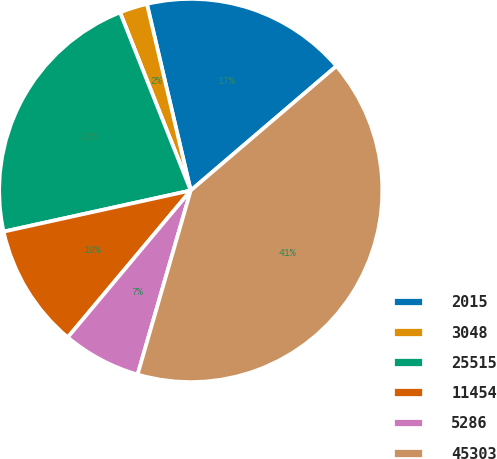Convert chart to OTSL. <chart><loc_0><loc_0><loc_500><loc_500><pie_chart><fcel>2015<fcel>3048<fcel>25515<fcel>11454<fcel>5286<fcel>45303<nl><fcel>17.42%<fcel>2.34%<fcel>22.43%<fcel>10.46%<fcel>6.62%<fcel>40.72%<nl></chart> 